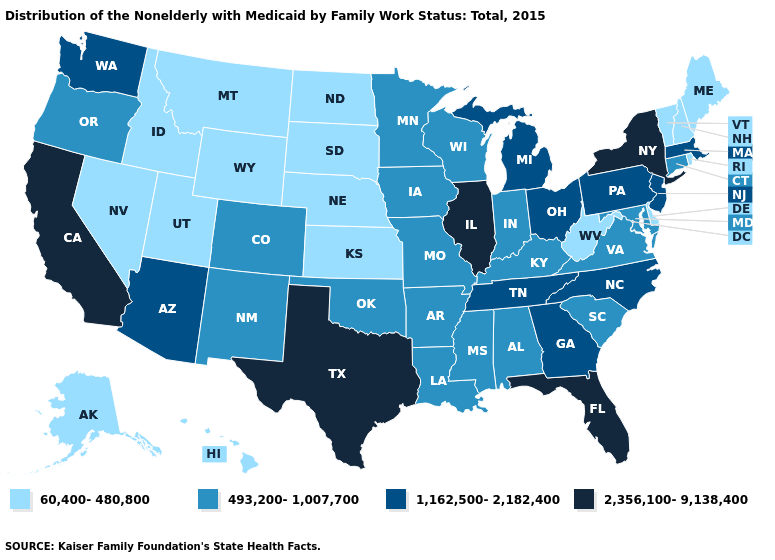Among the states that border Mississippi , does Alabama have the lowest value?
Concise answer only. Yes. Name the states that have a value in the range 60,400-480,800?
Keep it brief. Alaska, Delaware, Hawaii, Idaho, Kansas, Maine, Montana, Nebraska, Nevada, New Hampshire, North Dakota, Rhode Island, South Dakota, Utah, Vermont, West Virginia, Wyoming. Which states have the lowest value in the South?
Short answer required. Delaware, West Virginia. Which states have the highest value in the USA?
Short answer required. California, Florida, Illinois, New York, Texas. Does the first symbol in the legend represent the smallest category?
Short answer required. Yes. What is the value of Nebraska?
Answer briefly. 60,400-480,800. Which states have the highest value in the USA?
Give a very brief answer. California, Florida, Illinois, New York, Texas. Does Massachusetts have a higher value than New York?
Be succinct. No. What is the highest value in the USA?
Concise answer only. 2,356,100-9,138,400. Which states have the highest value in the USA?
Quick response, please. California, Florida, Illinois, New York, Texas. What is the value of Pennsylvania?
Quick response, please. 1,162,500-2,182,400. What is the value of New Hampshire?
Concise answer only. 60,400-480,800. What is the highest value in the Northeast ?
Short answer required. 2,356,100-9,138,400. What is the value of South Dakota?
Be succinct. 60,400-480,800. Name the states that have a value in the range 2,356,100-9,138,400?
Short answer required. California, Florida, Illinois, New York, Texas. 